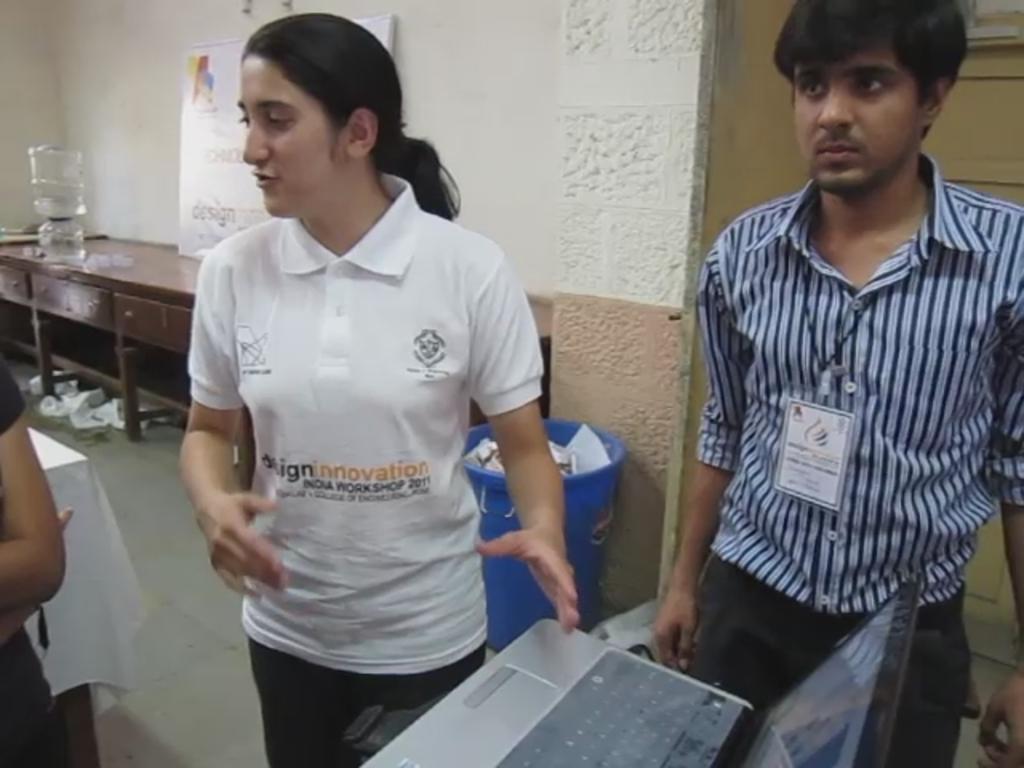In one or two sentences, can you explain what this image depicts? In this image a woman is standing. At the right side there is a man. Back to this woman a dustbin is there. Left side there is a person standing behind her there is a table. There is a water can on a table which is closer to the wall having a poster. 